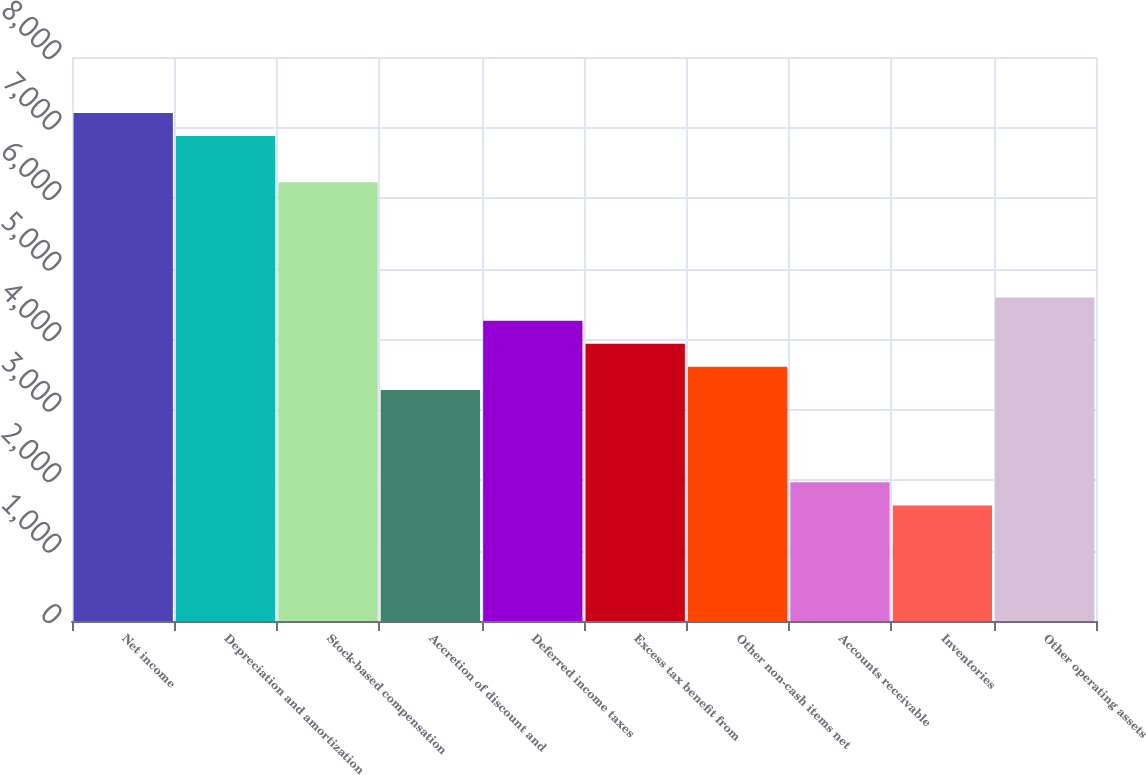Convert chart to OTSL. <chart><loc_0><loc_0><loc_500><loc_500><bar_chart><fcel>Net income<fcel>Depreciation and amortization<fcel>Stock-based compensation<fcel>Accretion of discount and<fcel>Deferred income taxes<fcel>Excess tax benefit from<fcel>Other non-cash items net<fcel>Accounts receivable<fcel>Inventories<fcel>Other operating assets<nl><fcel>7207.34<fcel>6879.82<fcel>6224.78<fcel>3277.1<fcel>4259.66<fcel>3932.14<fcel>3604.62<fcel>1967.02<fcel>1639.5<fcel>4587.18<nl></chart> 